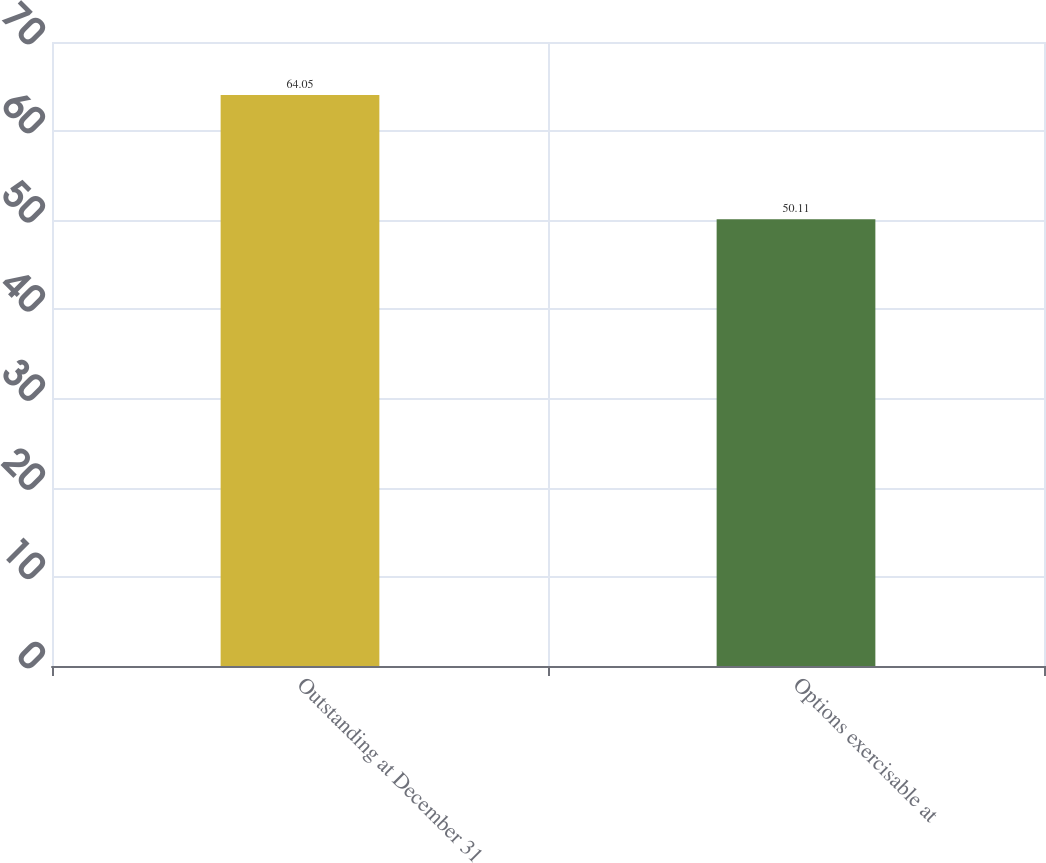<chart> <loc_0><loc_0><loc_500><loc_500><bar_chart><fcel>Outstanding at December 31<fcel>Options exercisable at<nl><fcel>64.05<fcel>50.11<nl></chart> 